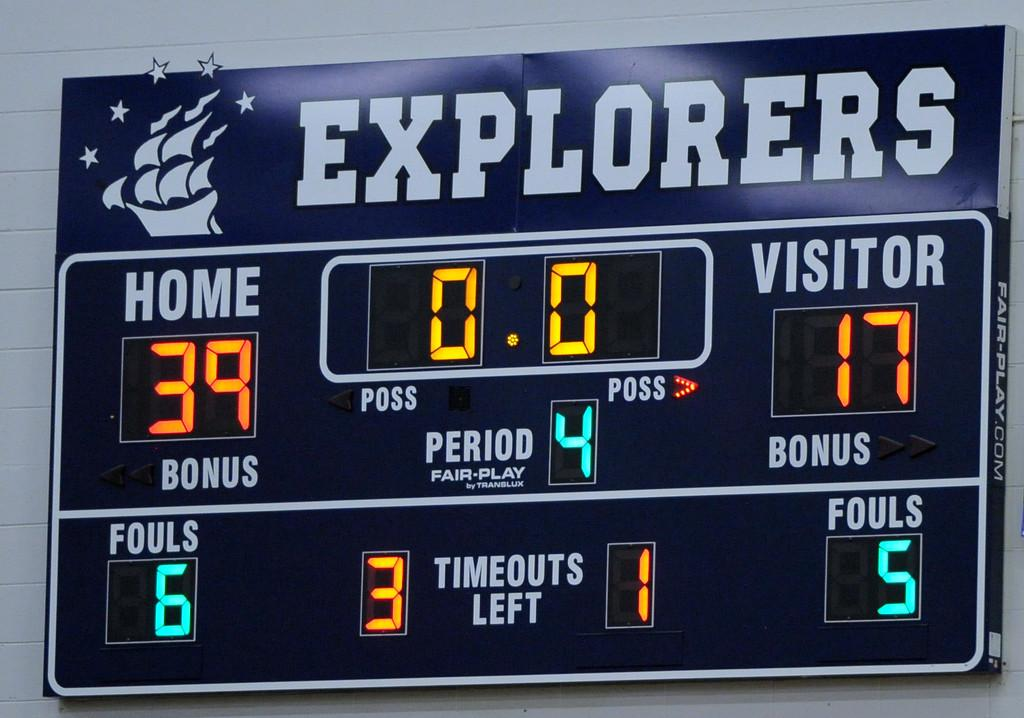Provide a one-sentence caption for the provided image. The score for the Explorers game is 39-17. 